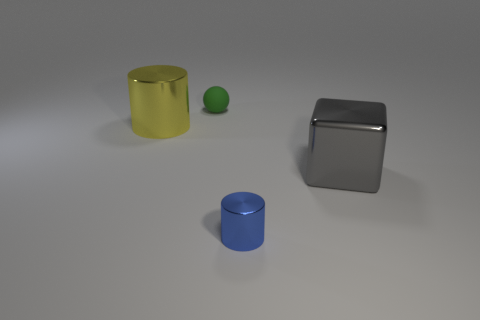Add 3 rubber spheres. How many objects exist? 7 Subtract all spheres. How many objects are left? 3 Add 2 brown shiny cylinders. How many brown shiny cylinders exist? 2 Subtract 0 cyan balls. How many objects are left? 4 Subtract all tiny green things. Subtract all yellow cylinders. How many objects are left? 2 Add 4 tiny objects. How many tiny objects are left? 6 